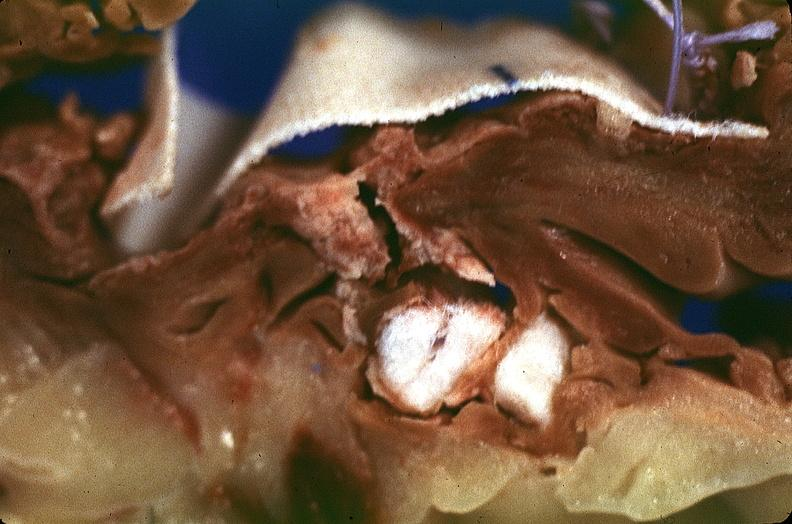does notochord show heart, myocardial infarction, surgery to repair interventricular septum rupture?
Answer the question using a single word or phrase. No 